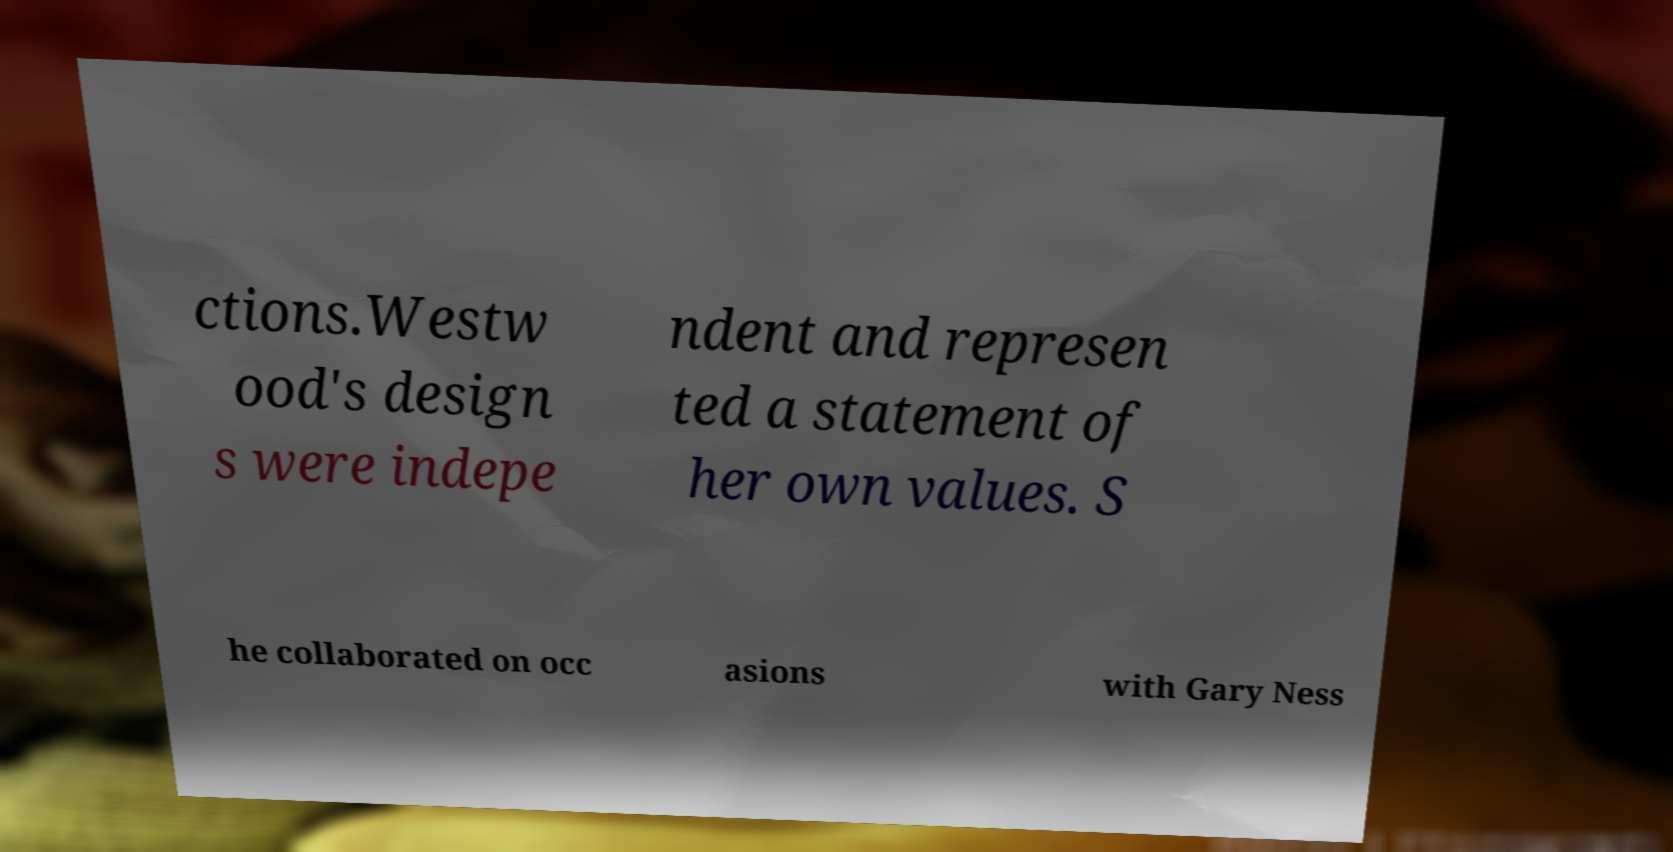Can you read and provide the text displayed in the image?This photo seems to have some interesting text. Can you extract and type it out for me? ctions.Westw ood's design s were indepe ndent and represen ted a statement of her own values. S he collaborated on occ asions with Gary Ness 